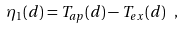Convert formula to latex. <formula><loc_0><loc_0><loc_500><loc_500>\eta _ { 1 } ( d ) = T _ { a p } ( d ) - T _ { e x } ( d ) \ ,</formula> 